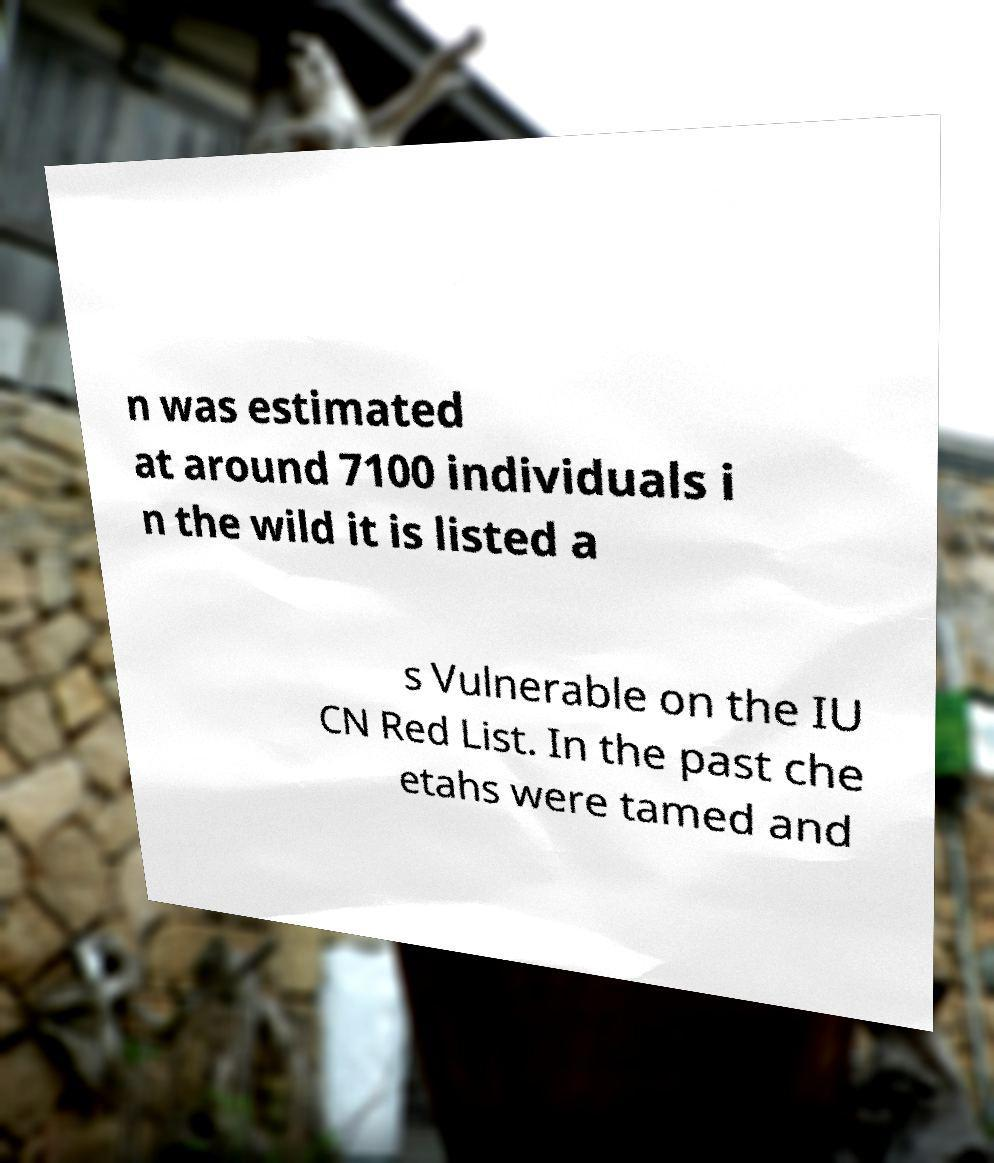There's text embedded in this image that I need extracted. Can you transcribe it verbatim? n was estimated at around 7100 individuals i n the wild it is listed a s Vulnerable on the IU CN Red List. In the past che etahs were tamed and 